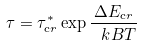Convert formula to latex. <formula><loc_0><loc_0><loc_500><loc_500>\tau = \tau ^ { * } _ { \mathrm c r } \exp { \frac { \Delta E _ { \mathrm c r } } { \ k B T } }</formula> 